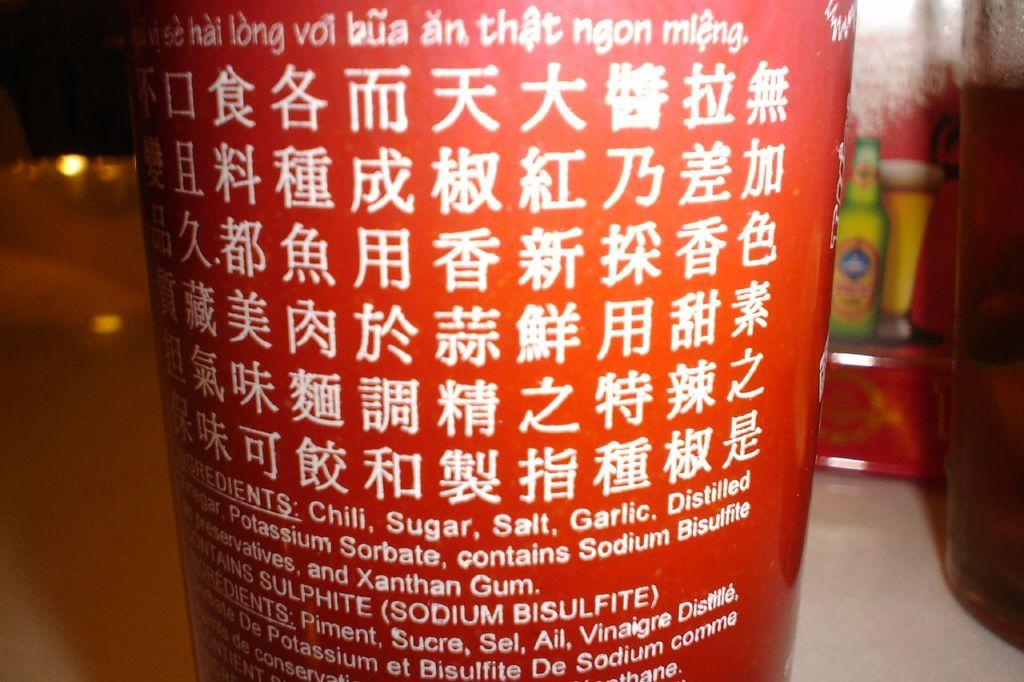<image>
Offer a succinct explanation of the picture presented. A bottle of Chinese chili sauce with Chili, sugar and salt being the first 3 ingredients. 